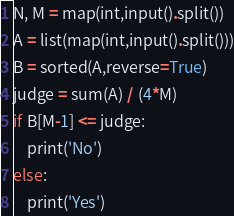Convert code to text. <code><loc_0><loc_0><loc_500><loc_500><_Python_>N, M = map(int,input().split())
A = list(map(int,input().split()))
B = sorted(A,reverse=True)
judge = sum(A) / (4*M)
if B[M-1] <= judge:
    print('No')
else:
    print('Yes')</code> 